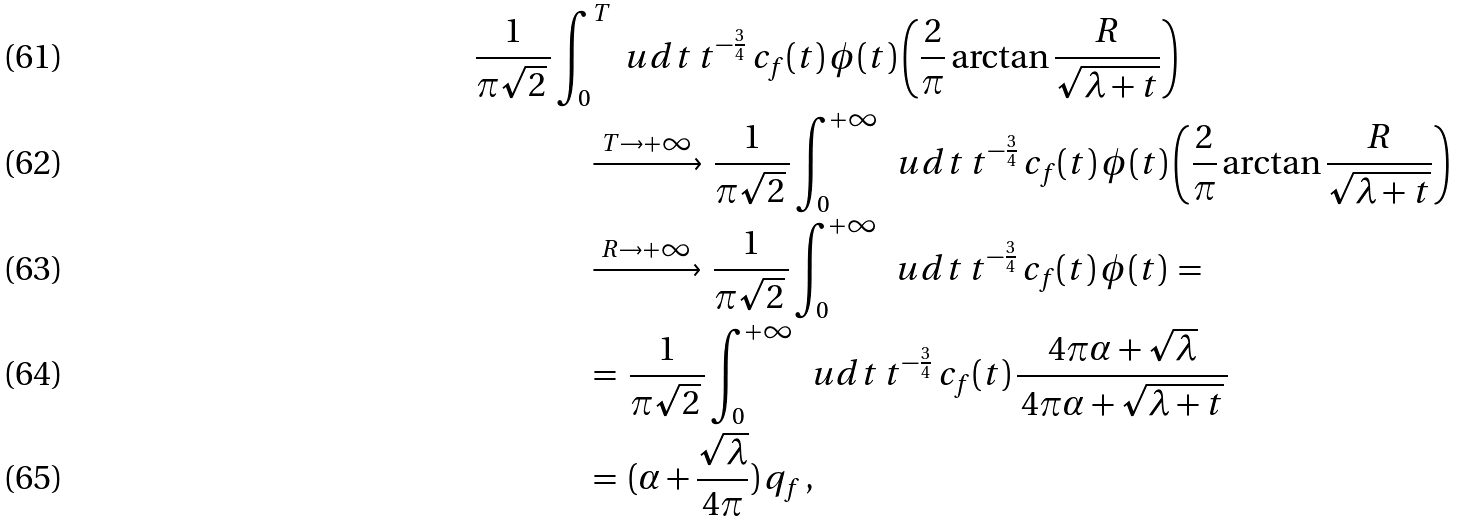<formula> <loc_0><loc_0><loc_500><loc_500>\frac { 1 } { \pi \sqrt { 2 } \, } & \int _ { 0 } ^ { T } \ u d t \, t ^ { - \frac { 3 } { 4 } } \, c _ { f } ( t ) \, \phi ( t ) \left ( { \frac { 2 } { \pi } \arctan \frac { R } { \sqrt { \lambda + t } } } \right ) \\ & \quad \xrightarrow [ ] { \, T \to + \infty \, } \, \frac { 1 } { \pi \sqrt { 2 } \, } \int _ { 0 } ^ { + \infty } \, \ u d t \, t ^ { - \frac { 3 } { 4 } } \, c _ { f } ( t ) \, \phi ( t ) \left ( { \frac { 2 } { \pi } \arctan \frac { R } { \sqrt { \lambda + t } } } \right ) \\ & \quad \xrightarrow [ ] { \, R \to + \infty \, } \, \frac { 1 } { \pi \sqrt { 2 } \, } \int _ { 0 } ^ { + \infty } \, \ u d t \, t ^ { - \frac { 3 } { 4 } } \, c _ { f } ( t ) \, \phi ( t ) \, = \, \\ & \quad = \, \frac { 1 } { \pi \sqrt { 2 } \, } \int _ { 0 } ^ { + \infty } \, \ u d t \, t ^ { - \frac { 3 } { 4 } } \, c _ { f } ( t ) \, \frac { 4 \pi \alpha + \sqrt { \lambda } } { \, 4 \pi \alpha + \sqrt { \lambda + t } \, } \\ & \quad = \, ( \alpha + { \frac { \sqrt { \lambda } } { 4 \pi } } ) \, q _ { f } \, ,</formula> 